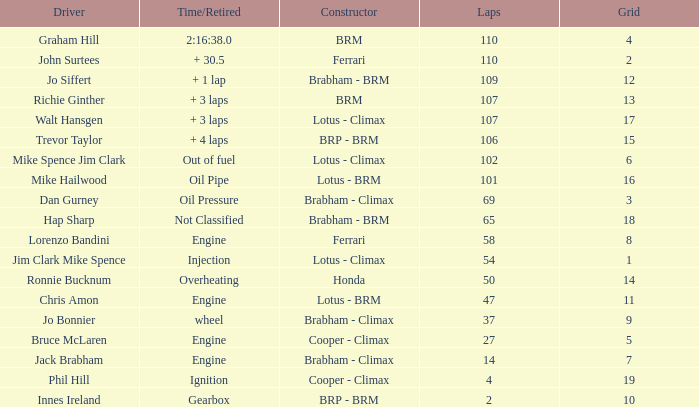What time/retired for grid 18? Not Classified. 